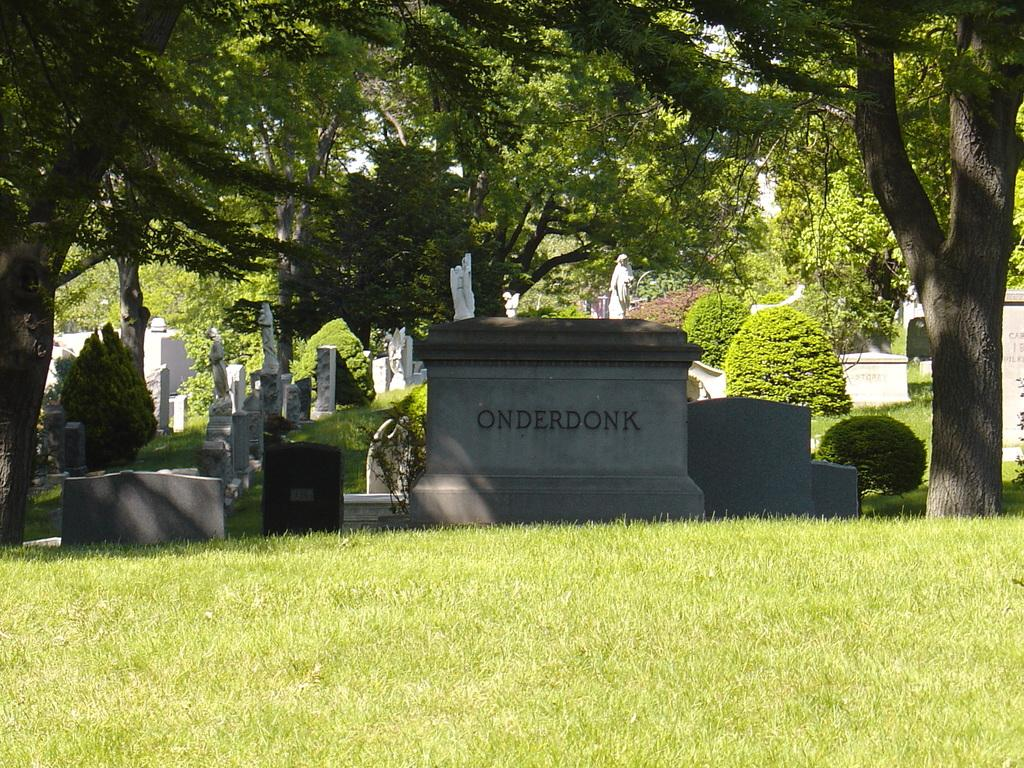What is the main object in the image? There is a headstone in the image. What other objects can be seen in the image? There are sculptures in the image. What type of natural environment is visible in the image? There is grass, plants, and trees visible in the image. How many plants does the person in the image have on their legs? There is no person present in the image, and therefore no one has plants on their legs. 